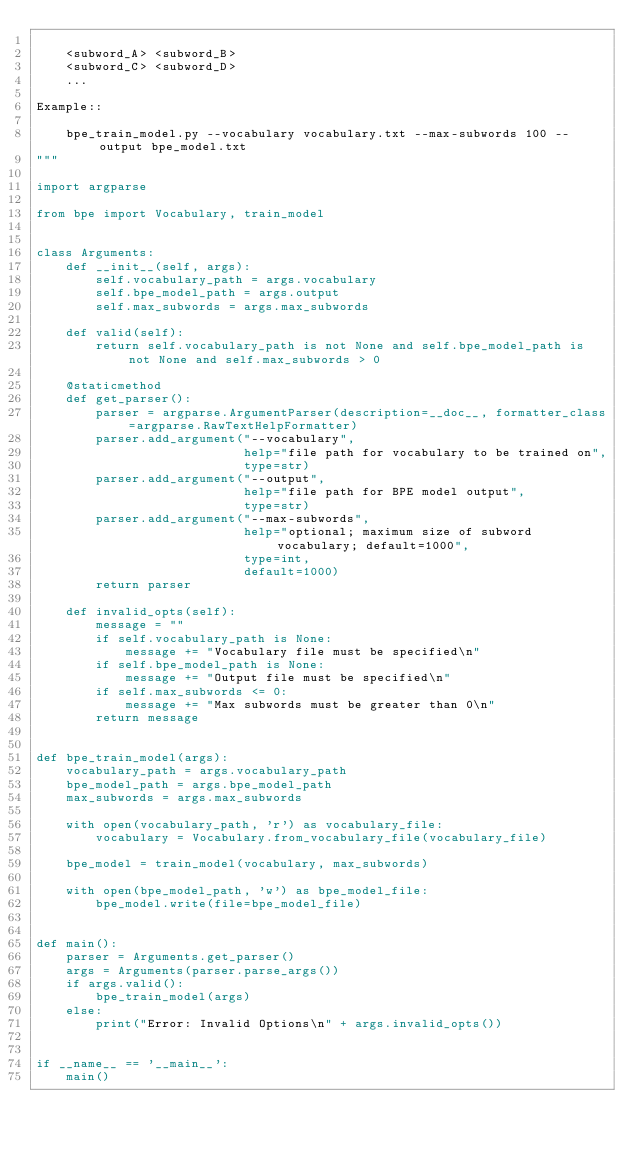<code> <loc_0><loc_0><loc_500><loc_500><_Python_>
    <subword_A> <subword_B>
    <subword_C> <subword_D>
    ...

Example::

    bpe_train_model.py --vocabulary vocabulary.txt --max-subwords 100 --output bpe_model.txt
"""

import argparse

from bpe import Vocabulary, train_model


class Arguments:
    def __init__(self, args):
        self.vocabulary_path = args.vocabulary
        self.bpe_model_path = args.output
        self.max_subwords = args.max_subwords

    def valid(self):
        return self.vocabulary_path is not None and self.bpe_model_path is not None and self.max_subwords > 0

    @staticmethod
    def get_parser():
        parser = argparse.ArgumentParser(description=__doc__, formatter_class=argparse.RawTextHelpFormatter)
        parser.add_argument("--vocabulary",
                            help="file path for vocabulary to be trained on",
                            type=str)
        parser.add_argument("--output",
                            help="file path for BPE model output",
                            type=str)
        parser.add_argument("--max-subwords",
                            help="optional; maximum size of subword vocabulary; default=1000",
                            type=int,
                            default=1000)
        return parser

    def invalid_opts(self):
        message = ""
        if self.vocabulary_path is None:
            message += "Vocabulary file must be specified\n"
        if self.bpe_model_path is None:
            message += "Output file must be specified\n"
        if self.max_subwords <= 0:
            message += "Max subwords must be greater than 0\n"
        return message


def bpe_train_model(args):
    vocabulary_path = args.vocabulary_path
    bpe_model_path = args.bpe_model_path
    max_subwords = args.max_subwords

    with open(vocabulary_path, 'r') as vocabulary_file:
        vocabulary = Vocabulary.from_vocabulary_file(vocabulary_file)

    bpe_model = train_model(vocabulary, max_subwords)

    with open(bpe_model_path, 'w') as bpe_model_file:
        bpe_model.write(file=bpe_model_file)


def main():
    parser = Arguments.get_parser()
    args = Arguments(parser.parse_args())
    if args.valid():
        bpe_train_model(args)
    else:
        print("Error: Invalid Options\n" + args.invalid_opts())


if __name__ == '__main__':
    main()
</code> 